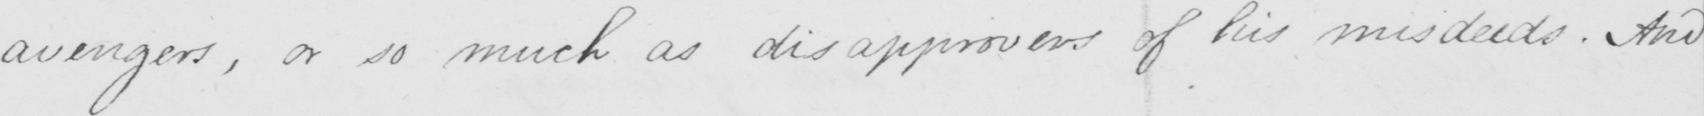Can you tell me what this handwritten text says? avengers , or so much as disapprovers of his misdeeds . And 